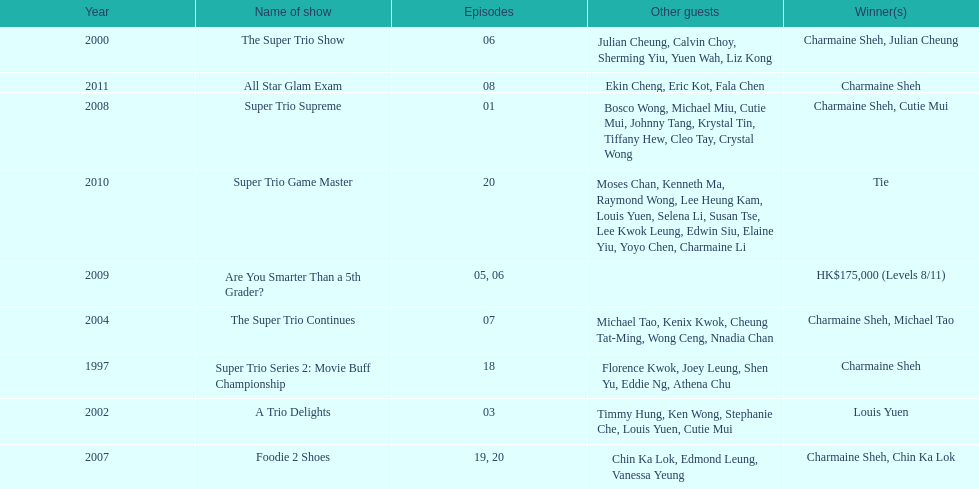What year was the only year were a tie occurred? 2010. 